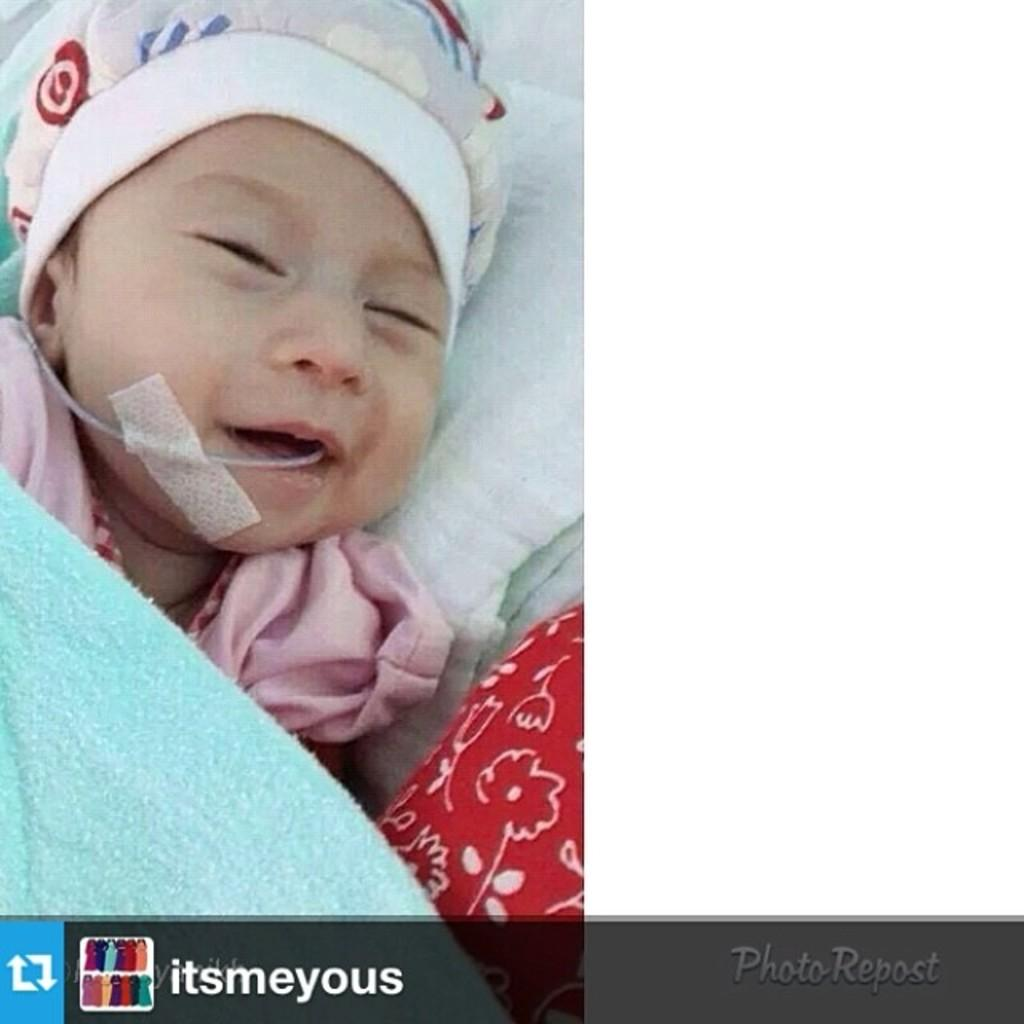What is the main subject of the image? There is a kid sleeping in the image. What color is the towel in the image? The towel in the image is blue. What is the color of the cloth at the bottom of the image? The cloth at the bottom of the image is white. How many fingers can be seen on the kid's hand in the image? There is no visible hand or fingers of the kid in the image, as they are sleeping. What is the weather like in the image? The facts provided do not mention any information about the weather or rain in the image. 